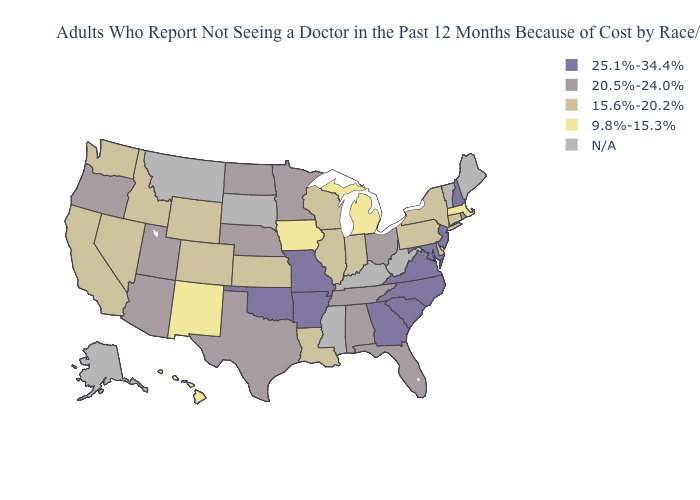What is the value of Florida?
Concise answer only. 20.5%-24.0%. What is the value of Utah?
Concise answer only. 20.5%-24.0%. Does Iowa have the lowest value in the MidWest?
Concise answer only. Yes. Name the states that have a value in the range 9.8%-15.3%?
Answer briefly. Hawaii, Iowa, Massachusetts, Michigan, New Mexico. What is the value of Washington?
Be succinct. 15.6%-20.2%. Name the states that have a value in the range 15.6%-20.2%?
Answer briefly. California, Colorado, Connecticut, Delaware, Idaho, Illinois, Indiana, Kansas, Louisiana, Nevada, New York, Pennsylvania, Washington, Wisconsin, Wyoming. What is the highest value in states that border Pennsylvania?
Answer briefly. 25.1%-34.4%. Name the states that have a value in the range N/A?
Answer briefly. Alaska, Kentucky, Maine, Mississippi, Montana, South Dakota, Vermont, West Virginia. What is the value of Texas?
Write a very short answer. 20.5%-24.0%. What is the highest value in the USA?
Concise answer only. 25.1%-34.4%. Name the states that have a value in the range 15.6%-20.2%?
Give a very brief answer. California, Colorado, Connecticut, Delaware, Idaho, Illinois, Indiana, Kansas, Louisiana, Nevada, New York, Pennsylvania, Washington, Wisconsin, Wyoming. Among the states that border Arkansas , does Texas have the highest value?
Be succinct. No. What is the value of New Jersey?
Concise answer only. 25.1%-34.4%. What is the highest value in the MidWest ?
Short answer required. 25.1%-34.4%. Name the states that have a value in the range 25.1%-34.4%?
Write a very short answer. Arkansas, Georgia, Maryland, Missouri, New Hampshire, New Jersey, North Carolina, Oklahoma, South Carolina, Virginia. 